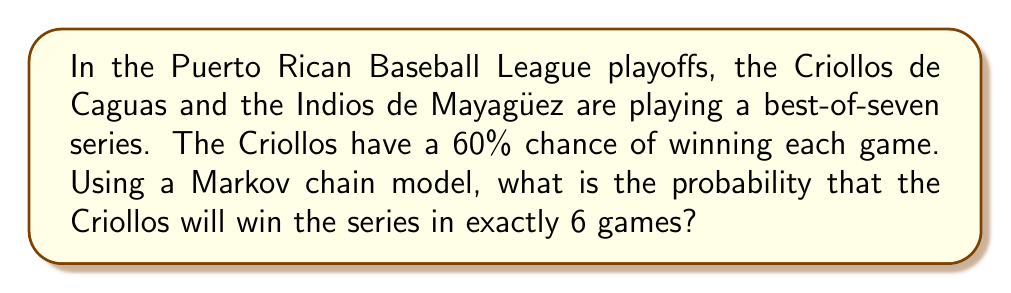Show me your answer to this math problem. Let's approach this step-by-step using a Markov chain model:

1) First, we need to define our states. Let's represent the state as (x,y), where x is the number of wins for the Criollos and y is the number of wins for the Indios.

2) The possible transitions from each state are:
   - Win for Criollos (probability 0.6)
   - Win for Indios (probability 0.4)

3) To win in exactly 6 games, the Criollos must win 4 games and lose 2 games in the first 5 games, and then win the 6th game.

4) The number of ways to win 4 games out of 5 is $\binom{5}{4} = 5$.

5) For each of these 5 possible paths, the probability is:

   $$P(\text{path}) = (0.6)^4 \cdot (0.4)^1 = 0.07776$$

6) The probability of winning the 6th game is 0.6.

7) Therefore, the total probability is:

   $$P(\text{win in 6}) = 5 \cdot 0.07776 \cdot 0.6$$

8) Calculating:

   $$P(\text{win in 6}) = 5 \cdot 0.07776 \cdot 0.6 = 0.23328$$

Thus, the probability that the Criollos will win the series in exactly 6 games is approximately 0.23328 or 23.328%.
Answer: 0.23328 